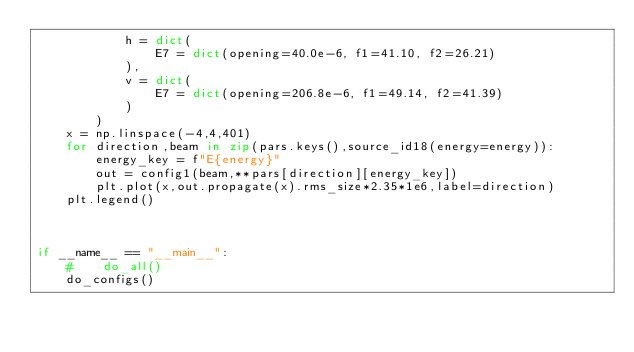Convert code to text. <code><loc_0><loc_0><loc_500><loc_500><_Python_>            h = dict(
                E7 = dict(opening=40.0e-6, f1=41.10, f2=26.21)
            ),
            v = dict(
                E7 = dict(opening=206.8e-6, f1=49.14, f2=41.39)
            )
        )
    x = np.linspace(-4,4,401)
    for direction,beam in zip(pars.keys(),source_id18(energy=energy)):
        energy_key = f"E{energy}"
        out = config1(beam,**pars[direction][energy_key])
        plt.plot(x,out.propagate(x).rms_size*2.35*1e6,label=direction)
    plt.legend()



if __name__ == "__main__":
    #    do_all()
    do_configs()
</code> 